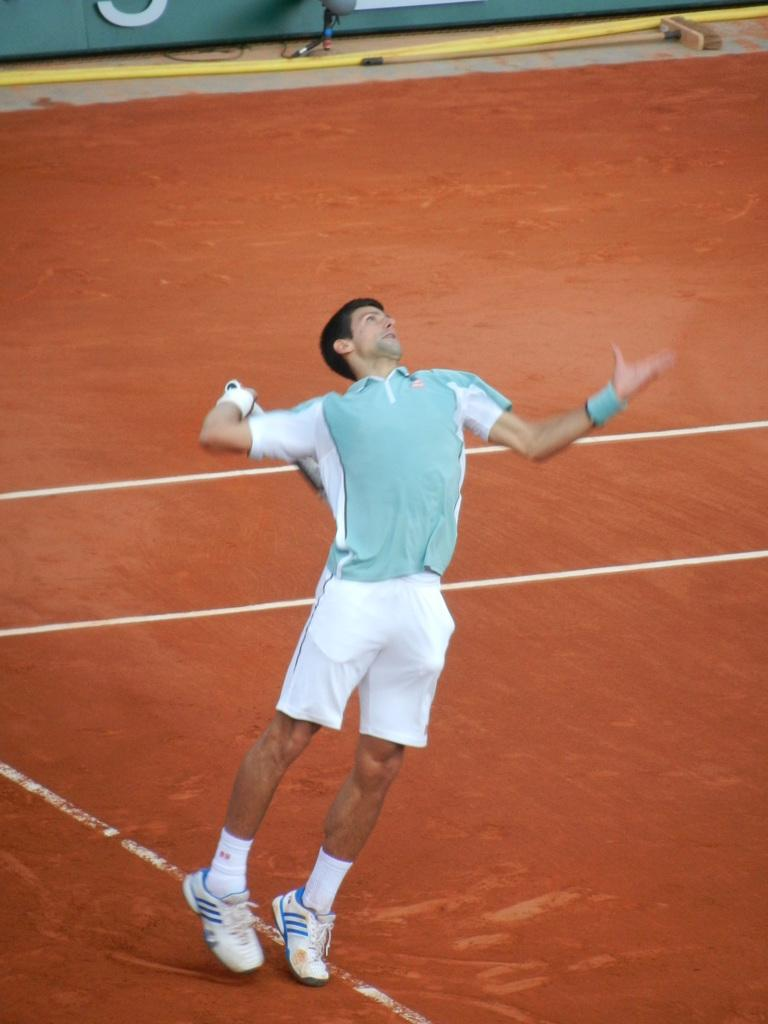Where is the image taken? The image is inside a playground. Who is present in the image? There is a man in the image. What is the man holding in the image? The man is holding a racket. What is the man doing with the racket? The man is playing with the racket. What color is the land visible at the bottom of the image? The land at the bottom of the image is red-colored. What type of tax can be seen being paid in the image? There is no tax being paid in the image; it features a man playing with a racket in a playground. What smell is associated with the red-colored land in the image? There is no mention of a smell in the image, and the red-colored land is not described as having a specific scent. 